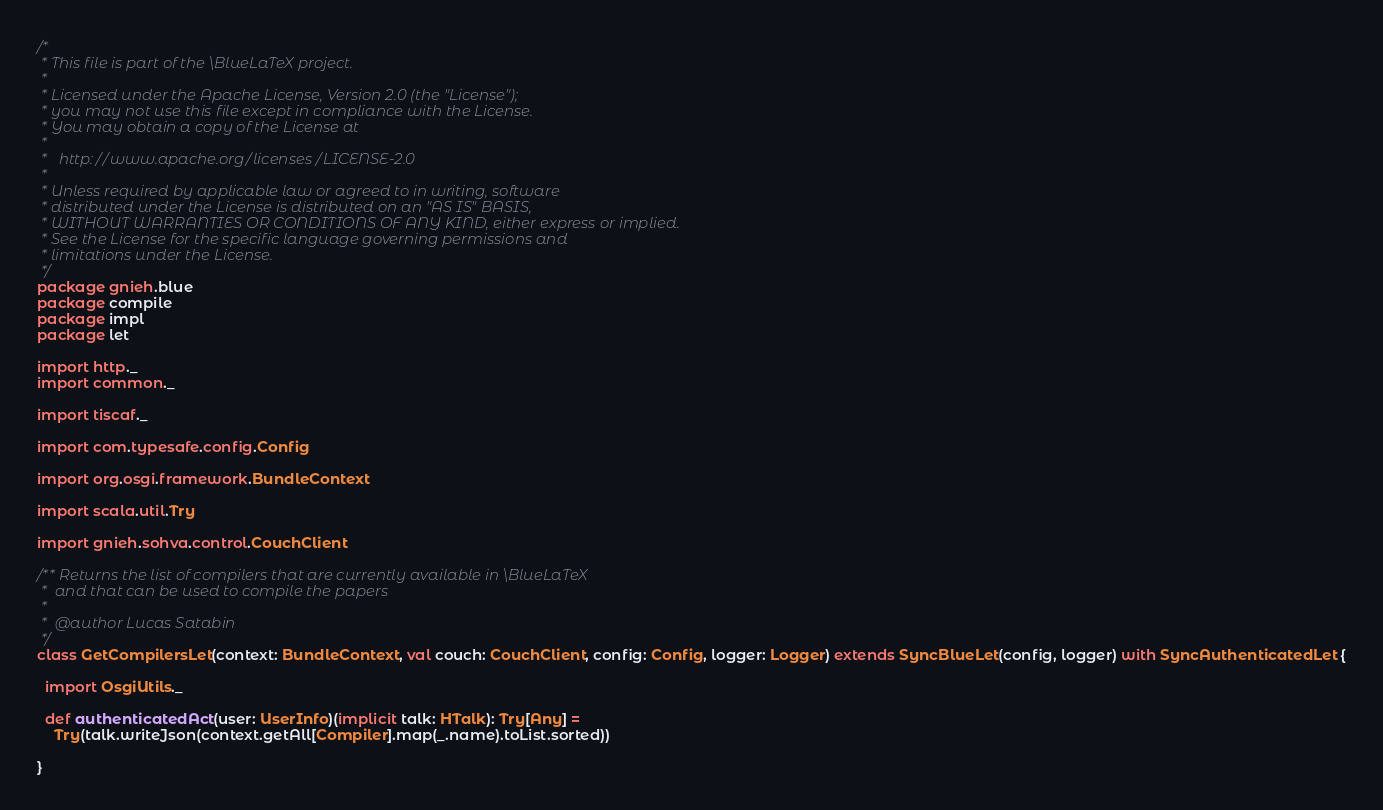<code> <loc_0><loc_0><loc_500><loc_500><_Scala_>/*
 * This file is part of the \BlueLaTeX project.
 *
 * Licensed under the Apache License, Version 2.0 (the "License");
 * you may not use this file except in compliance with the License.
 * You may obtain a copy of the License at
 *
 *   http://www.apache.org/licenses/LICENSE-2.0
 *
 * Unless required by applicable law or agreed to in writing, software
 * distributed under the License is distributed on an "AS IS" BASIS,
 * WITHOUT WARRANTIES OR CONDITIONS OF ANY KIND, either express or implied.
 * See the License for the specific language governing permissions and
 * limitations under the License.
 */
package gnieh.blue
package compile
package impl
package let

import http._
import common._

import tiscaf._

import com.typesafe.config.Config

import org.osgi.framework.BundleContext

import scala.util.Try

import gnieh.sohva.control.CouchClient

/** Returns the list of compilers that are currently available in \BlueLaTeX
 *  and that can be used to compile the papers
 *
 *  @author Lucas Satabin
 */
class GetCompilersLet(context: BundleContext, val couch: CouchClient, config: Config, logger: Logger) extends SyncBlueLet(config, logger) with SyncAuthenticatedLet {

  import OsgiUtils._

  def authenticatedAct(user: UserInfo)(implicit talk: HTalk): Try[Any] =
    Try(talk.writeJson(context.getAll[Compiler].map(_.name).toList.sorted))

}

</code> 